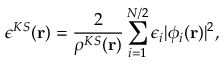<formula> <loc_0><loc_0><loc_500><loc_500>\epsilon ^ { K S } ( r ) = \frac { 2 } { \rho ^ { K S } ( r ) } \sum _ { i = 1 } ^ { N / 2 } \epsilon _ { i } | \phi _ { i } ( r ) | ^ { 2 } ,</formula> 